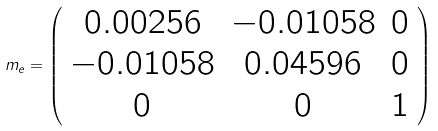<formula> <loc_0><loc_0><loc_500><loc_500>m _ { e } = \left ( \begin{array} { c c c } 0 . 0 0 2 5 6 & - 0 . 0 1 0 5 8 & 0 \\ - 0 . 0 1 0 5 8 & 0 . 0 4 5 9 6 & 0 \\ 0 & 0 & 1 \end{array} \right )</formula> 